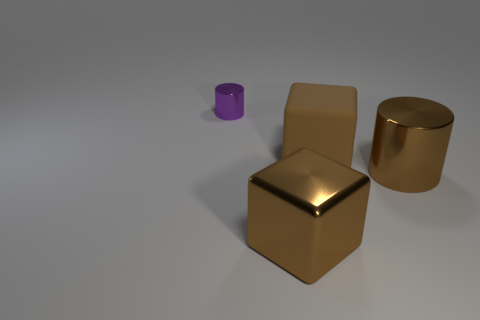Subtract all red blocks. Subtract all cyan spheres. How many blocks are left? 2 Add 4 tiny cylinders. How many objects exist? 8 Subtract all tiny brown cylinders. Subtract all big matte cubes. How many objects are left? 3 Add 2 large brown things. How many large brown things are left? 5 Add 3 brown shiny cubes. How many brown shiny cubes exist? 4 Subtract 0 blue cylinders. How many objects are left? 4 